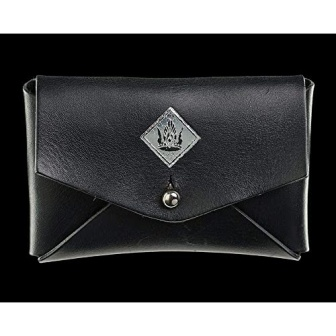What would be potential occasions to use a wallet like this? This classy and elegant looking wallet seems ideal for formal events or professional settings where making a refined and stylish impression is important. Its sleek design and compact size make it suitable for evenings out or business meetings, where you might need to carry essential items like ID, credit cards, and cash in a discreet yet fashionable way. 